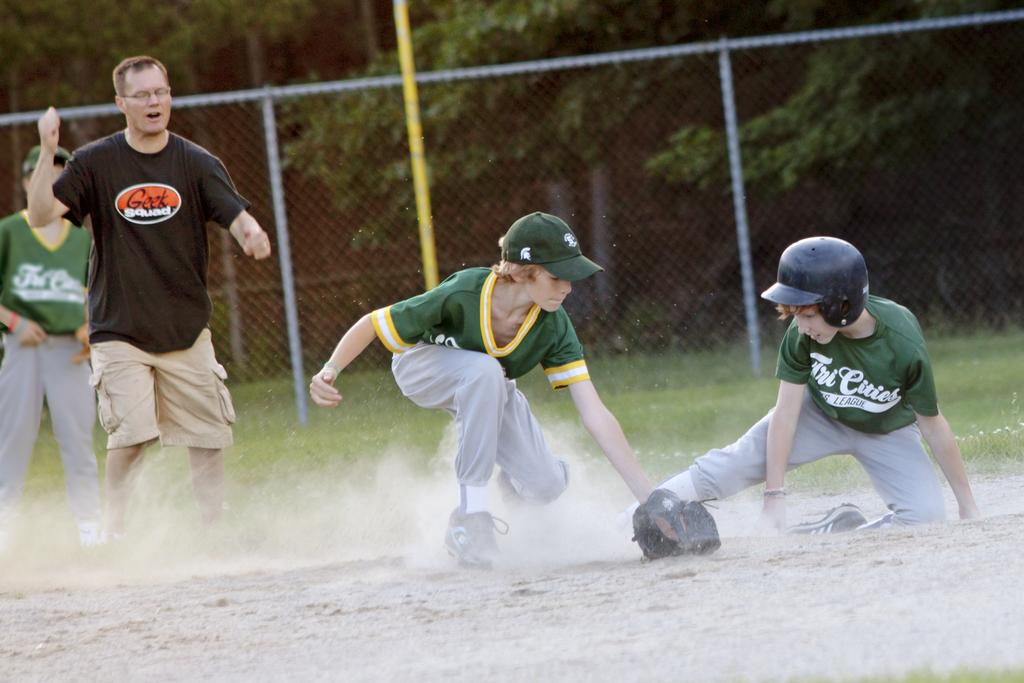What are the two boys in the image doing? The two boys in the image are playing. What color are the t-shirts and pants worn by the boys? The boys are wearing green t-shirts and green pants. How many people are present in the image? There are two people in the image. What can be seen in the background of the image? There is a pole, fencing, and trees in the background of the image. Can you tell me how many wings are visible on the boys in the image? There are no wings visible on the boys in the image; they are wearing green t-shirts and pants. 